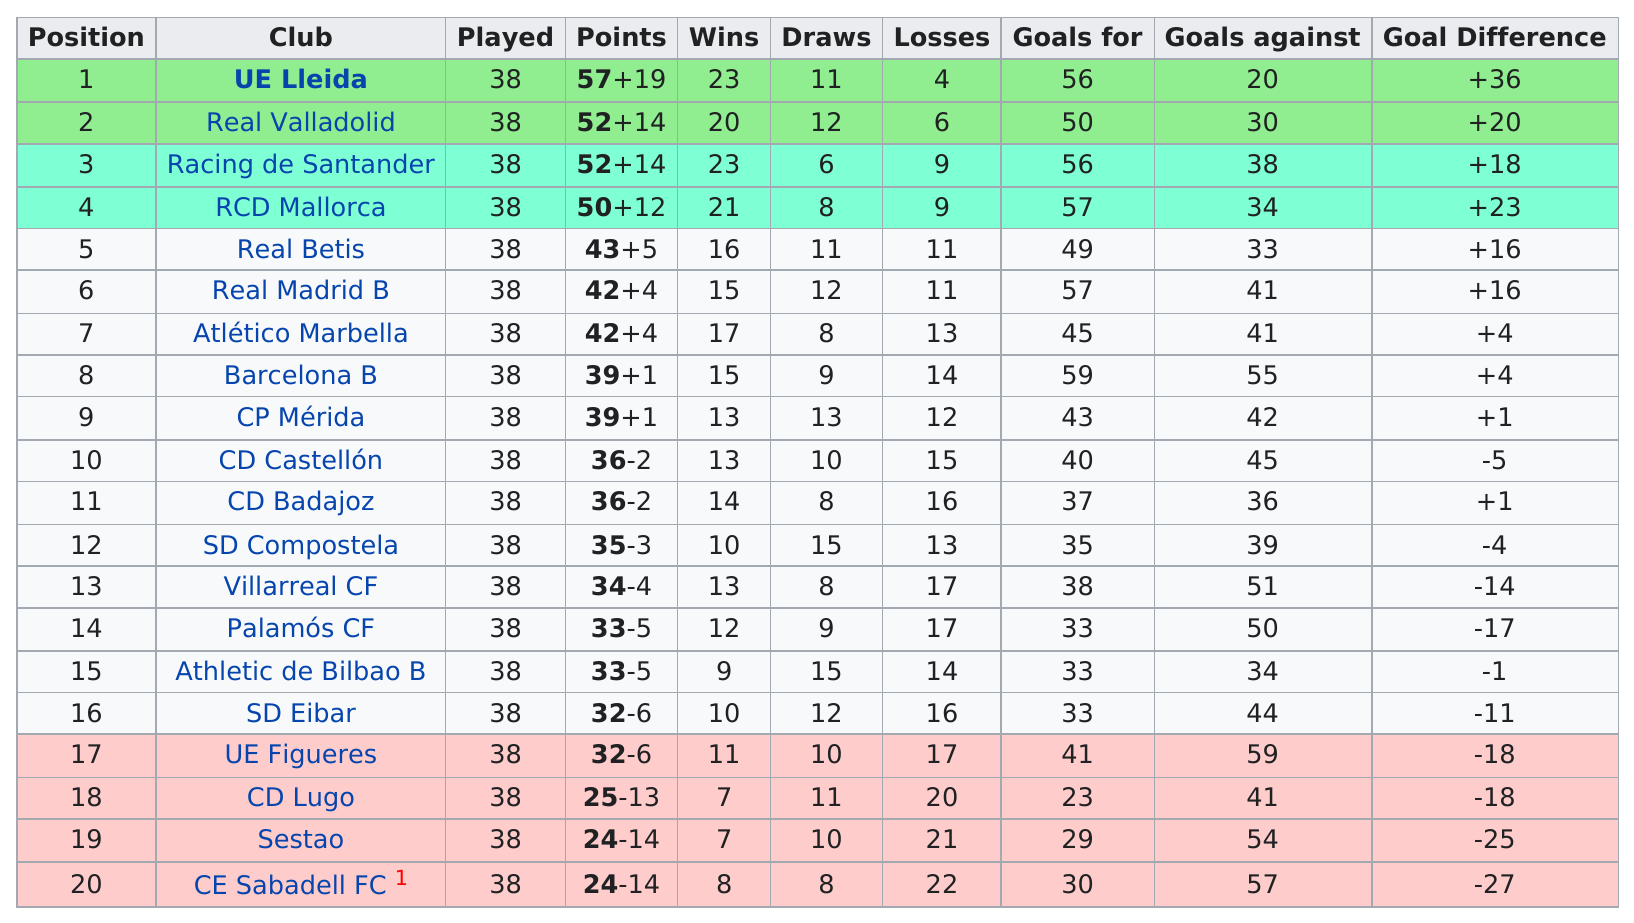Mention a couple of crucial points in this snapshot. Out of the 10 clubs, how many had a positive goal difference? Real Madrid B is the name of the next club after Real Betis. There were a total of 16 times when there were 10 or more losses. Out of the total number of teams, four had fewer than ten wins. The first club listed on this chart is UE Lleida. 